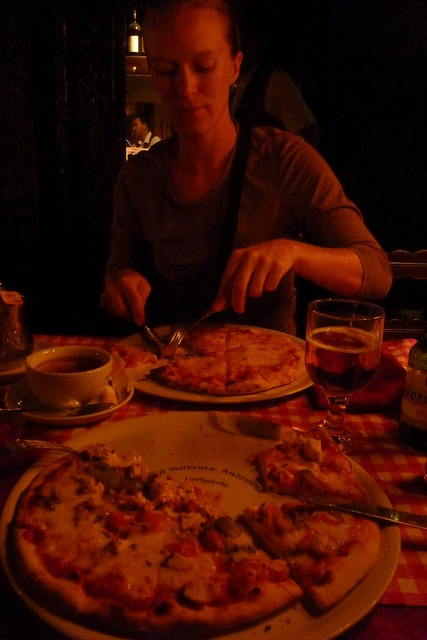Describe the objects in this image and their specific colors. I can see dining table in black, maroon, and brown tones, people in black, maroon, and brown tones, pizza in black, maroon, and brown tones, pizza in black, maroon, and brown tones, and pizza in black, maroon, and brown tones in this image. 